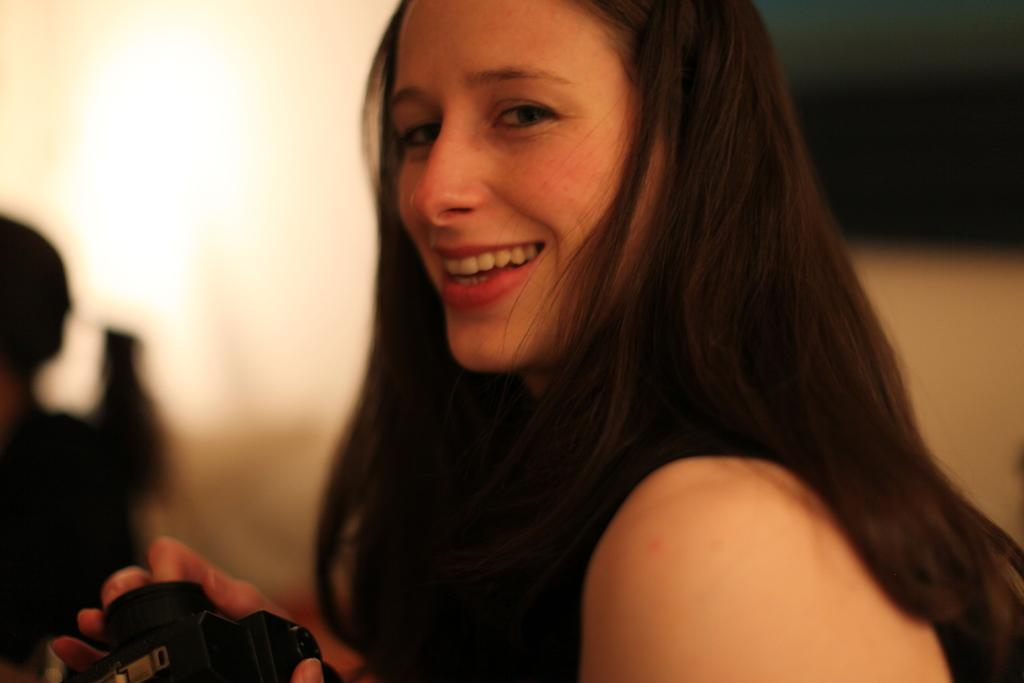Who is present in the image? There is a woman in the image. What is the woman doing in the image? The woman is smiling in the image. What object is the woman holding in the image? The woman is holding a camera in the image. What type of honey is the woman collecting in the image? There is no honey or honey collection activity present in the image. How many corn stalks can be seen behind the woman in the image? There is no corn or corn stalks present in the image. 